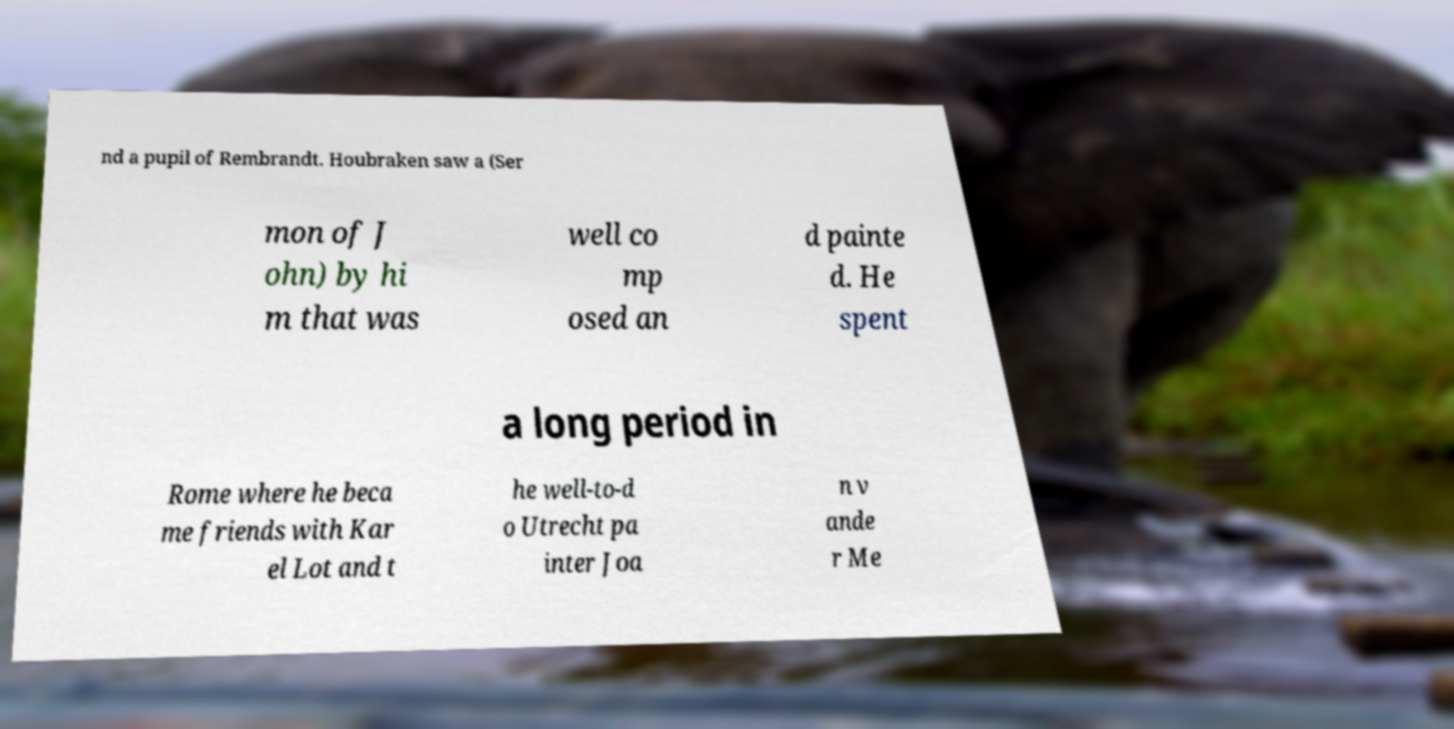Can you read and provide the text displayed in the image?This photo seems to have some interesting text. Can you extract and type it out for me? nd a pupil of Rembrandt. Houbraken saw a (Ser mon of J ohn) by hi m that was well co mp osed an d painte d. He spent a long period in Rome where he beca me friends with Kar el Lot and t he well-to-d o Utrecht pa inter Joa n v ande r Me 